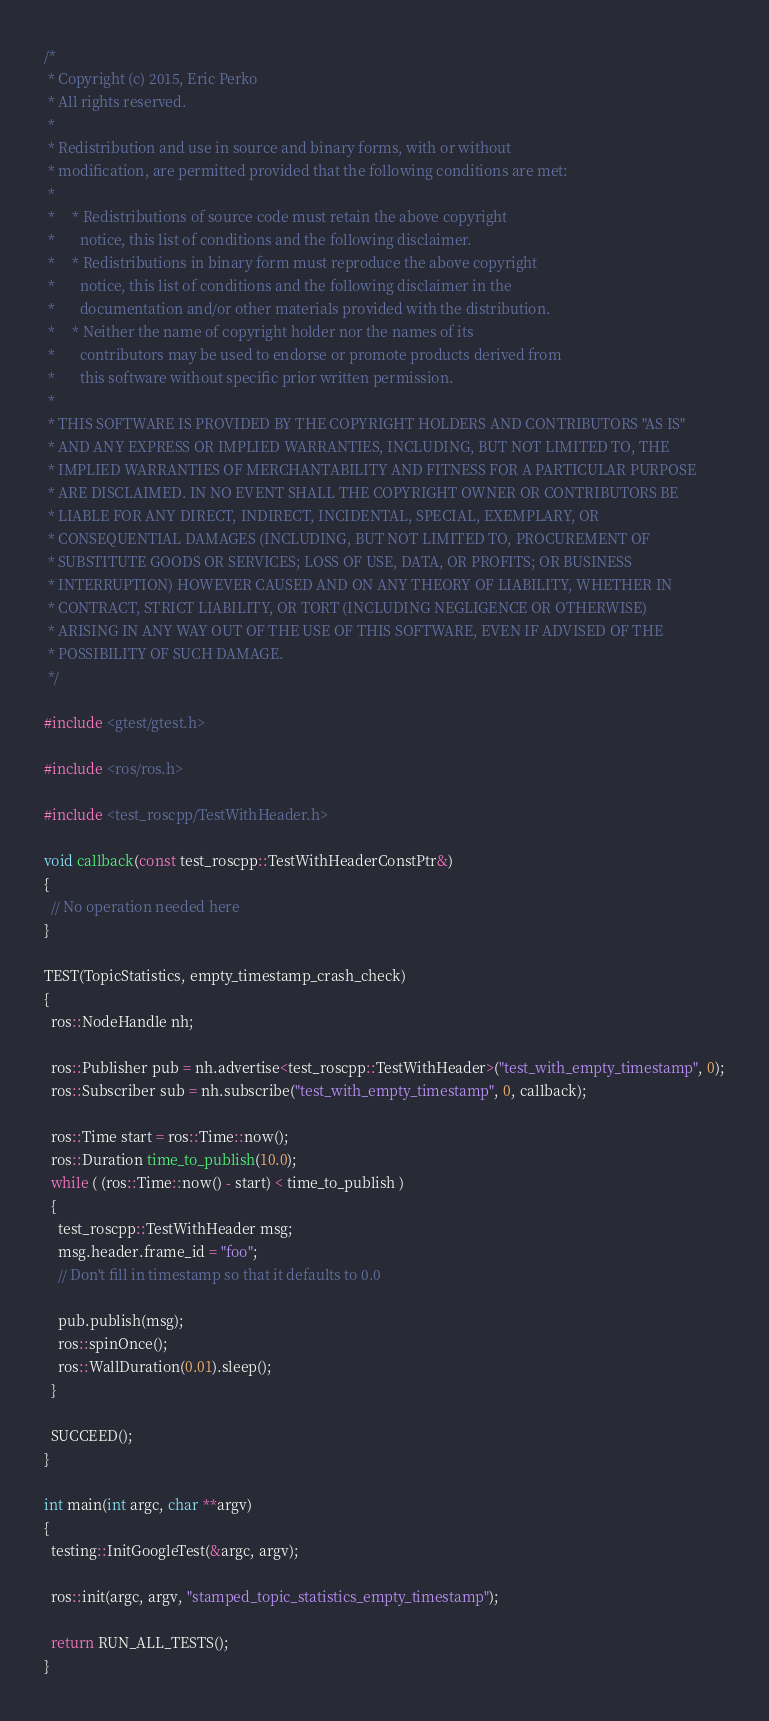<code> <loc_0><loc_0><loc_500><loc_500><_C++_>/*
 * Copyright (c) 2015, Eric Perko
 * All rights reserved.
 *
 * Redistribution and use in source and binary forms, with or without
 * modification, are permitted provided that the following conditions are met:
 *
 *     * Redistributions of source code must retain the above copyright
 *       notice, this list of conditions and the following disclaimer.
 *     * Redistributions in binary form must reproduce the above copyright
 *       notice, this list of conditions and the following disclaimer in the
 *       documentation and/or other materials provided with the distribution.
 *     * Neither the name of copyright holder nor the names of its
 *       contributors may be used to endorse or promote products derived from
 *       this software without specific prior written permission.
 *
 * THIS SOFTWARE IS PROVIDED BY THE COPYRIGHT HOLDERS AND CONTRIBUTORS "AS IS"
 * AND ANY EXPRESS OR IMPLIED WARRANTIES, INCLUDING, BUT NOT LIMITED TO, THE
 * IMPLIED WARRANTIES OF MERCHANTABILITY AND FITNESS FOR A PARTICULAR PURPOSE
 * ARE DISCLAIMED. IN NO EVENT SHALL THE COPYRIGHT OWNER OR CONTRIBUTORS BE
 * LIABLE FOR ANY DIRECT, INDIRECT, INCIDENTAL, SPECIAL, EXEMPLARY, OR
 * CONSEQUENTIAL DAMAGES (INCLUDING, BUT NOT LIMITED TO, PROCUREMENT OF
 * SUBSTITUTE GOODS OR SERVICES; LOSS OF USE, DATA, OR PROFITS; OR BUSINESS
 * INTERRUPTION) HOWEVER CAUSED AND ON ANY THEORY OF LIABILITY, WHETHER IN
 * CONTRACT, STRICT LIABILITY, OR TORT (INCLUDING NEGLIGENCE OR OTHERWISE)
 * ARISING IN ANY WAY OUT OF THE USE OF THIS SOFTWARE, EVEN IF ADVISED OF THE
 * POSSIBILITY OF SUCH DAMAGE.
 */

#include <gtest/gtest.h>

#include <ros/ros.h>

#include <test_roscpp/TestWithHeader.h>

void callback(const test_roscpp::TestWithHeaderConstPtr&)
{
  // No operation needed here
}

TEST(TopicStatistics, empty_timestamp_crash_check)
{
  ros::NodeHandle nh;

  ros::Publisher pub = nh.advertise<test_roscpp::TestWithHeader>("test_with_empty_timestamp", 0);
  ros::Subscriber sub = nh.subscribe("test_with_empty_timestamp", 0, callback);

  ros::Time start = ros::Time::now();
  ros::Duration time_to_publish(10.0);
  while ( (ros::Time::now() - start) < time_to_publish )
  {
    test_roscpp::TestWithHeader msg;
    msg.header.frame_id = "foo";
    // Don't fill in timestamp so that it defaults to 0.0

    pub.publish(msg);
    ros::spinOnce();
    ros::WallDuration(0.01).sleep();
  }

  SUCCEED();
}

int main(int argc, char **argv)
{
  testing::InitGoogleTest(&argc, argv);

  ros::init(argc, argv, "stamped_topic_statistics_empty_timestamp");

  return RUN_ALL_TESTS();
}</code> 